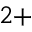Convert formula to latex. <formula><loc_0><loc_0><loc_500><loc_500>^ { 2 + }</formula> 